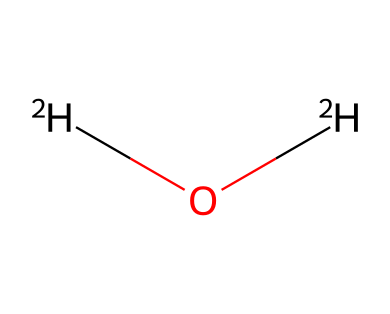How many hydrogen atoms are in this chemical? The chemical structure shows two deuterium atoms, which are represented as [2H]. The formula indicates the presence of two hydrogen atoms.
Answer: two What is the molecular formula of this compound? The SMILES representation [2H]O[2H] indicates three atoms: two deuterium atoms and one oxygen atom. Therefore, the molecular formula is D2O.
Answer: D2O What is the significance of deuterium in this compound? Deuterium is a stable isotope of hydrogen with an additional neutron, which alters some physical properties compared to regular hydrogen, affecting its behavior and stability in water.
Answer: alters properties Does this chemical have a different boiling point than regular water? Yes, deuterium-enriched water (D2O) has a higher boiling point than regular water (H2O) because of its greater mass.
Answer: yes How does deuterium-enriched water contribute to shelf life? D2O is less reactive than H2O and can inhibit microbial growth, thus extending shelf life of the product in emergency kits.
Answer: inhibits growth What type of chemical is represented by this SMILES structure? The structure represents an isotope of water specifically enriched with deuterium, classifying it as an isotopic compound.
Answer: isotopic compound What is the common use of deuterium-enriched water in emergency kits? It is used to enhance the shelf life of water supplies by reducing microbial activity, making it useful in emergency situations.
Answer: shelf life enhancement 